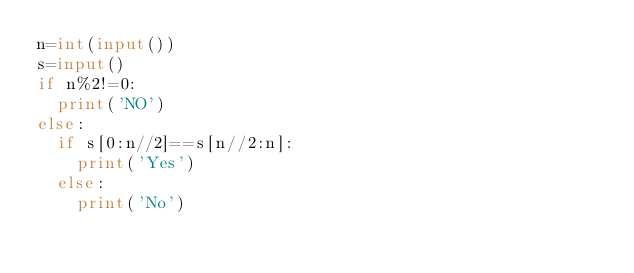<code> <loc_0><loc_0><loc_500><loc_500><_Python_>n=int(input())
s=input()
if n%2!=0:
  print('NO')
else:
  if s[0:n//2]==s[n//2:n]:
    print('Yes')
  else:
    print('No')</code> 